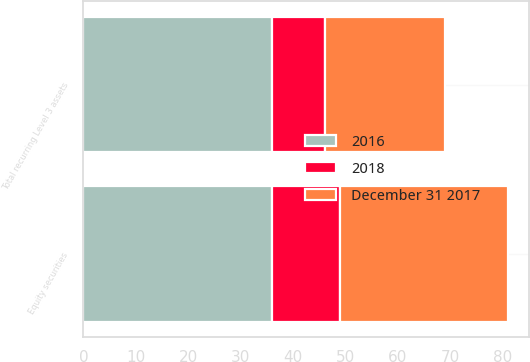<chart> <loc_0><loc_0><loc_500><loc_500><stacked_bar_chart><ecel><fcel>Equity securities<fcel>Total recurring Level 3 assets<nl><fcel>2016<fcel>36<fcel>36<nl><fcel>2018<fcel>13<fcel>10<nl><fcel>December 31 2017<fcel>32<fcel>23<nl></chart> 